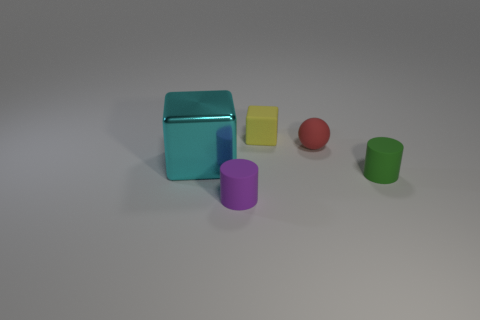Add 4 cyan rubber cylinders. How many objects exist? 9 Subtract all cylinders. How many objects are left? 3 Add 1 gray matte cubes. How many gray matte cubes exist? 1 Subtract 0 purple cubes. How many objects are left? 5 Subtract all red things. Subtract all small cyan rubber cylinders. How many objects are left? 4 Add 1 big blocks. How many big blocks are left? 2 